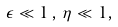<formula> <loc_0><loc_0><loc_500><loc_500>\epsilon \ll 1 \, , \, \eta \ll 1 ,</formula> 